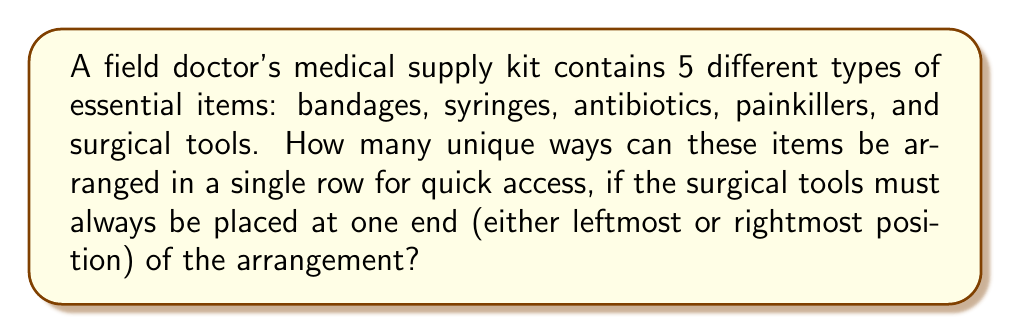Help me with this question. Let's approach this problem step-by-step using permutation groups:

1) First, we need to consider that the surgical tools have a restricted position (either leftmost or rightmost). This gives us two cases to consider.

2) For each case, we need to arrange the remaining 4 items.

3) The number of permutations for 4 items is given by $4! = 4 \times 3 \times 2 \times 1 = 24$.

4) Since we have two possible positions for the surgical tools (left or right), and for each of these positions, we have 24 permutations of the other items, we multiply our result by 2.

5) Therefore, the total number of unique arrangements is:

   $$ 2 \times 4! = 2 \times 24 = 48 $$

6) We can also express this using permutation group notation. If we denote the symmetric group on 5 elements as $S_5$, our problem is equivalent to finding the order of a subgroup of $S_5$ where one element (surgical tools) is restricted to two positions.

   $$ |H| = 2 \times |S_4| = 2 \times 4! = 48 $$

   Where $H$ is our subgroup of $S_5$ with the given restriction.

This result ensures that the field doctor has 48 different ways to organize the medical supplies for quick access while always having the surgical tools at one end.
Answer: 48 unique arrangements 